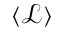<formula> <loc_0><loc_0><loc_500><loc_500>\langle \mathcal { L } \rangle</formula> 